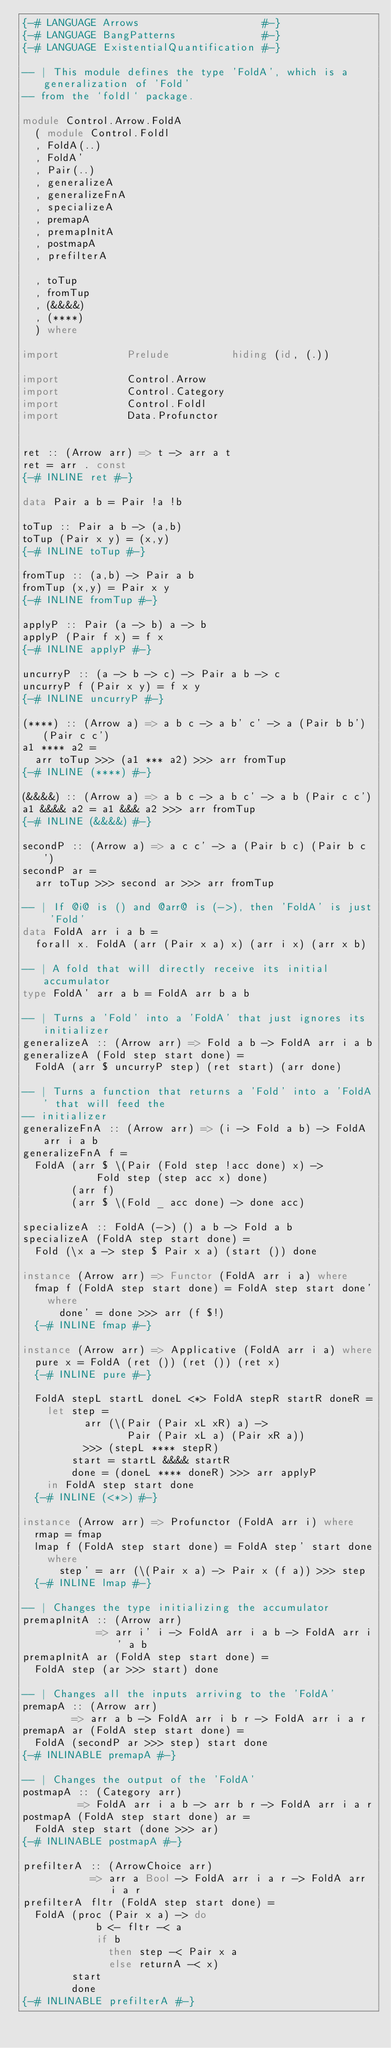<code> <loc_0><loc_0><loc_500><loc_500><_Haskell_>{-# LANGUAGE Arrows                    #-}
{-# LANGUAGE BangPatterns              #-}
{-# LANGUAGE ExistentialQuantification #-}

-- | This module defines the type 'FoldA', which is a generalization of 'Fold'
-- from the `foldl` package.

module Control.Arrow.FoldA
  ( module Control.Foldl
  , FoldA(..)
  , FoldA'
  , Pair(..)
  , generalizeA
  , generalizeFnA
  , specializeA
  , premapA
  , premapInitA
  , postmapA
  , prefilterA

  , toTup
  , fromTup
  , (&&&&)
  , (****)
  ) where

import           Prelude          hiding (id, (.))

import           Control.Arrow
import           Control.Category
import           Control.Foldl
import           Data.Profunctor


ret :: (Arrow arr) => t -> arr a t
ret = arr . const
{-# INLINE ret #-}

data Pair a b = Pair !a !b

toTup :: Pair a b -> (a,b)
toTup (Pair x y) = (x,y)
{-# INLINE toTup #-}

fromTup :: (a,b) -> Pair a b
fromTup (x,y) = Pair x y
{-# INLINE fromTup #-}

applyP :: Pair (a -> b) a -> b
applyP (Pair f x) = f x
{-# INLINE applyP #-}

uncurryP :: (a -> b -> c) -> Pair a b -> c
uncurryP f (Pair x y) = f x y
{-# INLINE uncurryP #-}

(****) :: (Arrow a) => a b c -> a b' c' -> a (Pair b b') (Pair c c')
a1 **** a2 =
  arr toTup >>> (a1 *** a2) >>> arr fromTup
{-# INLINE (****) #-}

(&&&&) :: (Arrow a) => a b c -> a b c' -> a b (Pair c c')
a1 &&&& a2 = a1 &&& a2 >>> arr fromTup
{-# INLINE (&&&&) #-}

secondP :: (Arrow a) => a c c' -> a (Pair b c) (Pair b c')
secondP ar =
  arr toTup >>> second ar >>> arr fromTup

-- | If @i@ is () and @arr@ is (->), then 'FoldA' is just 'Fold'
data FoldA arr i a b =
  forall x. FoldA (arr (Pair x a) x) (arr i x) (arr x b)

-- | A fold that will directly receive its initial accumulator
type FoldA' arr a b = FoldA arr b a b

-- | Turns a 'Fold' into a 'FoldA' that just ignores its initializer
generalizeA :: (Arrow arr) => Fold a b -> FoldA arr i a b
generalizeA (Fold step start done) =
  FoldA (arr $ uncurryP step) (ret start) (arr done)

-- | Turns a function that returns a 'Fold' into a 'FoldA' that will feed the
-- initializer
generalizeFnA :: (Arrow arr) => (i -> Fold a b) -> FoldA arr i a b
generalizeFnA f =
  FoldA (arr $ \(Pair (Fold step !acc done) x) ->
            Fold step (step acc x) done)
        (arr f)
        (arr $ \(Fold _ acc done) -> done acc)

specializeA :: FoldA (->) () a b -> Fold a b
specializeA (FoldA step start done) =
  Fold (\x a -> step $ Pair x a) (start ()) done

instance (Arrow arr) => Functor (FoldA arr i a) where
  fmap f (FoldA step start done) = FoldA step start done'
    where
      done' = done >>> arr (f $!)
  {-# INLINE fmap #-}

instance (Arrow arr) => Applicative (FoldA arr i a) where
  pure x = FoldA (ret ()) (ret ()) (ret x)
  {-# INLINE pure #-}

  FoldA stepL startL doneL <*> FoldA stepR startR doneR =
    let step =
          arr (\(Pair (Pair xL xR) a) ->
                 Pair (Pair xL a) (Pair xR a))
          >>> (stepL **** stepR)
        start = startL &&&& startR
        done = (doneL **** doneR) >>> arr applyP
    in FoldA step start done
  {-# INLINE (<*>) #-}

instance (Arrow arr) => Profunctor (FoldA arr i) where
  rmap = fmap
  lmap f (FoldA step start done) = FoldA step' start done
    where
      step' = arr (\(Pair x a) -> Pair x (f a)) >>> step
  {-# INLINE lmap #-}

-- | Changes the type initializing the accumulator
premapInitA :: (Arrow arr)
            => arr i' i -> FoldA arr i a b -> FoldA arr i' a b
premapInitA ar (FoldA step start done) =
  FoldA step (ar >>> start) done

-- | Changes all the inputs arriving to the 'FoldA'
premapA :: (Arrow arr)
        => arr a b -> FoldA arr i b r -> FoldA arr i a r
premapA ar (FoldA step start done) =
  FoldA (secondP ar >>> step) start done
{-# INLINABLE premapA #-}

-- | Changes the output of the 'FoldA'
postmapA :: (Category arr)
         => FoldA arr i a b -> arr b r -> FoldA arr i a r
postmapA (FoldA step start done) ar =
  FoldA step start (done >>> ar)
{-# INLINABLE postmapA #-}

prefilterA :: (ArrowChoice arr)
           => arr a Bool -> FoldA arr i a r -> FoldA arr i a r
prefilterA fltr (FoldA step start done) =
  FoldA (proc (Pair x a) -> do
            b <- fltr -< a
            if b
              then step -< Pair x a
              else returnA -< x)
        start
        done
{-# INLINABLE prefilterA #-}
</code> 